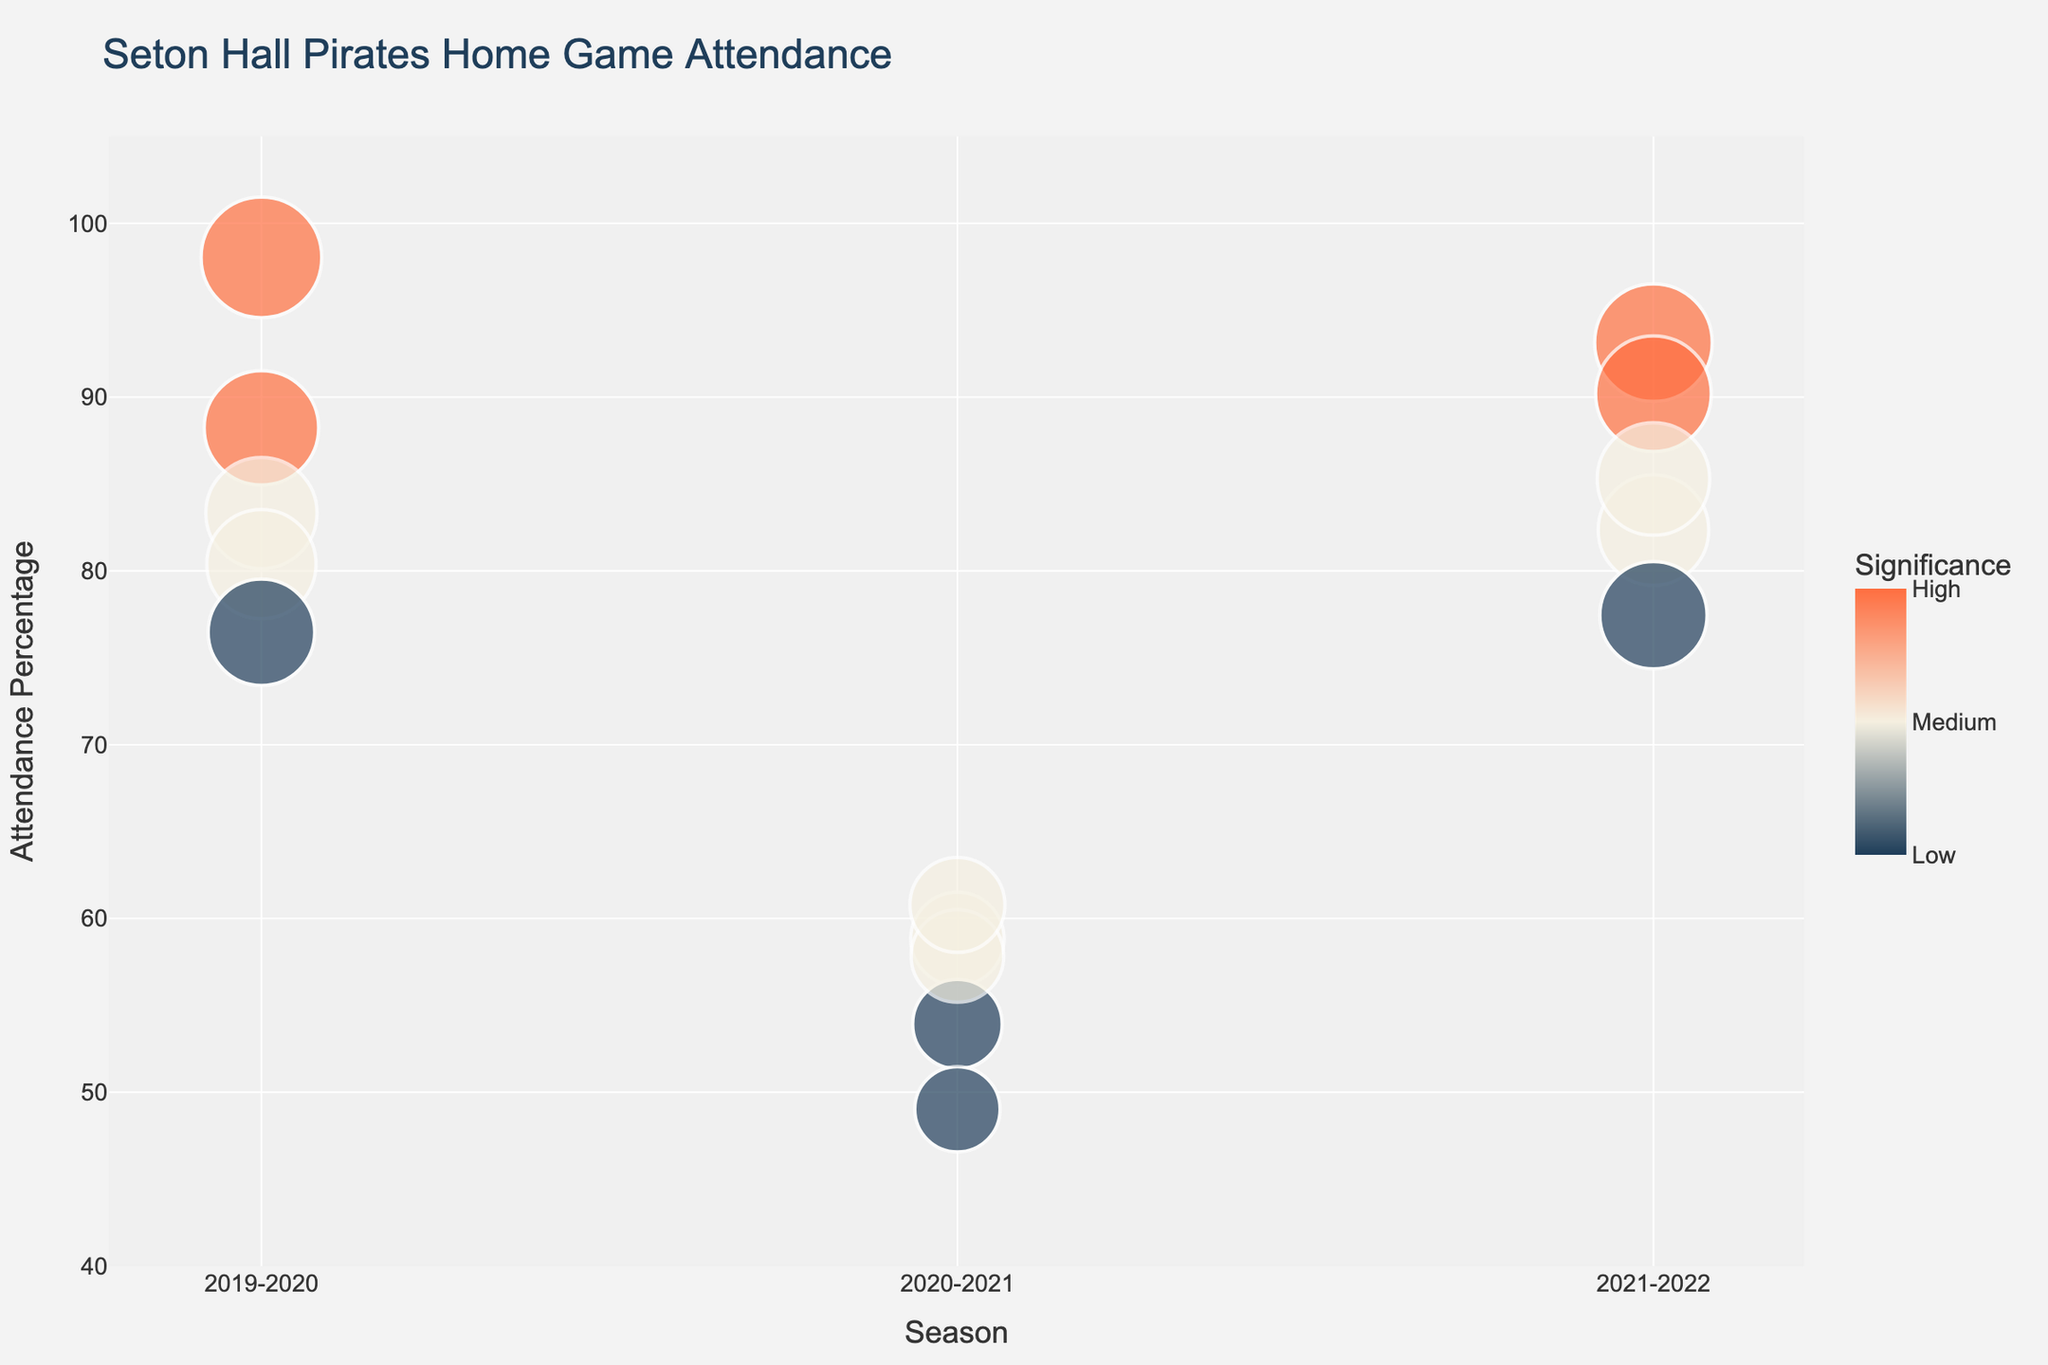How many games had an attendance percentage of over 90%? There are three games with attendance percentages exceeding 90%. These games are from the 2019-2020 season (Villanova) and the 2021-2022 season (UConn and Rutgers).
Answer: Three What's the average attendance percentage for games in the 2020-2021 season? There are five games in the 2020-2021 season. Their attendance percentages are 58.8% (Creighton), 53.9% (DePaul), 57.8% (Georgetown), 49.0% (Marquette), and 60.8% (Butler). The average attendance percentage is calculated as (58.8 + 53.9 + 57.8 + 49.0 + 60.8) / 5 = 280.3 / 5 = 56.06%.
Answer: 56.06% Which game had the highest attendance percentage? The game against Villanova in the 2019-2020 season had the highest attendance percentage, reaching approximately 98%.
Answer: Villanova (2019-2020) How many 'High' significance games are shown in the chart? There are four 'High' significance games: Michigan State (2019-2020), Villanova (2019-2020), UConn (2021-2022), and Rutgers (2021-2022).
Answer: Four Compare the highest attendance percentage in 2019-2020 with that in 2021-2022. Which is higher? The highest attendance percentage in 2019-2020 is for the game against Villanova (approximately 98%), while in 2021-2022, the highest is against UConn (approximately 93%). Therefore, the highest for 2019-2020 is higher.
Answer: 2019-2020 What is the total attendance for 'Medium' significance games across all seasons? The total attendance for 'Medium' significance games is calculated by summing the attendance for the following games: Providence (8500), St. John's (8200), Creighton (6000), Georgetown (5900), Butler (6200), Creighton (8400), and Marquette (8700). Therefore, the total is 8500 + 8200 + 6000 + 5900 + 6200 + 8400 + 8700 = 51900.
Answer: 51900 Which season had the lowest overall game attendance percentage and what was it? 2020-2021 season had the lowest overall game attendance percentage. By summing the attendance percentages (58.8, 53.9, 57.8, 49, 60.8) and averaging them, we get (58.8 + 53.9 + 57.8 + 49 + 60.8) / 5 = 56.06%. This is the lowest among the seasons.
Answer: 2020-2021, 56.06% How many games reached at least 80% of the MaxCapacity? There are five games that reached the attendance of at least 80% of the maximum capacity. These games are Villanova (2019-2020), Michigan State (2019-2020), Providence (2019-2020), UConn (2021-2022), and Rutgers (2021-2022).
Answer: Five 